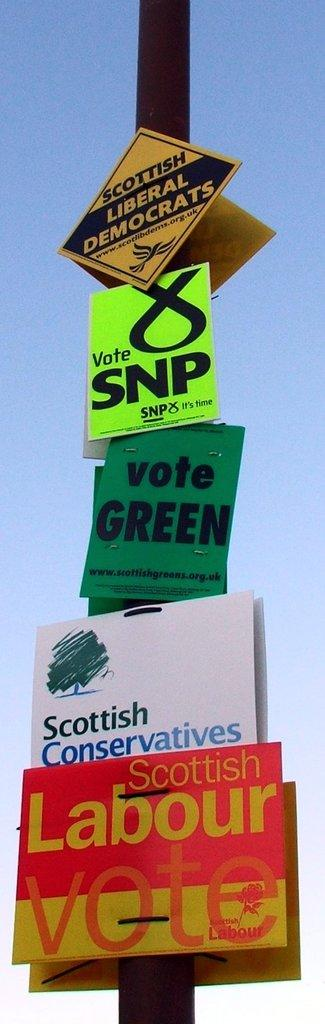<image>
Offer a succinct explanation of the picture presented. Five political flyers are attached to a pole, including ones saying "Vote Green" and "Vote SNP". 